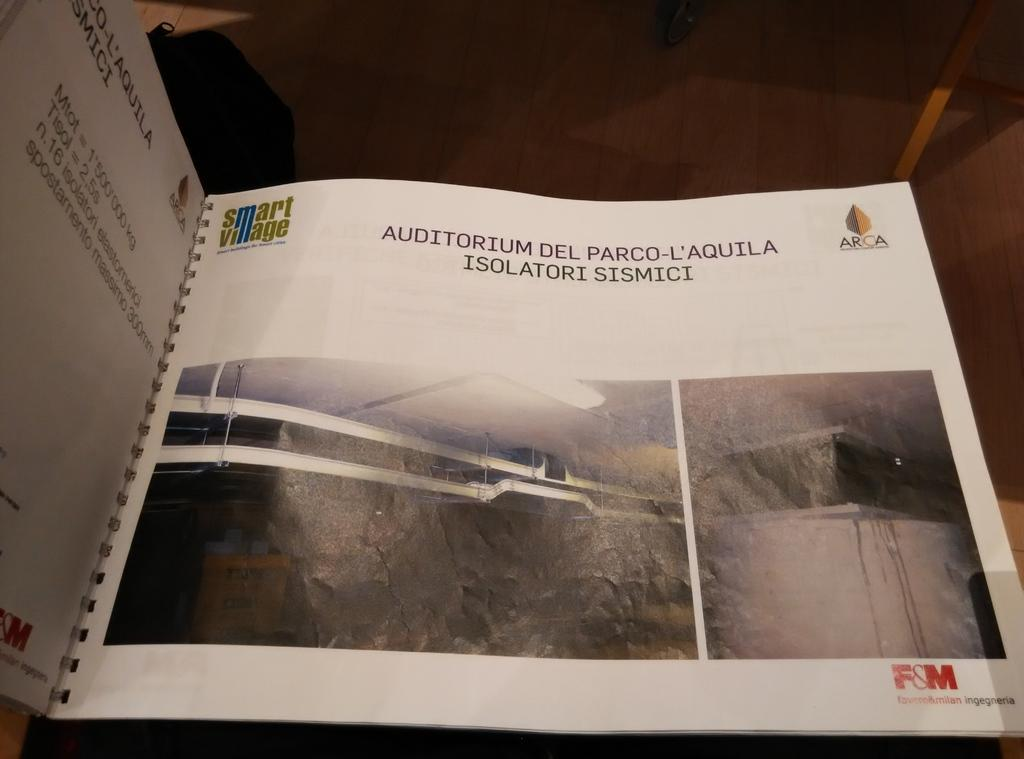<image>
Provide a brief description of the given image. The page of a spiral-bound book, which is about an Auditorium and written in Spanish. 